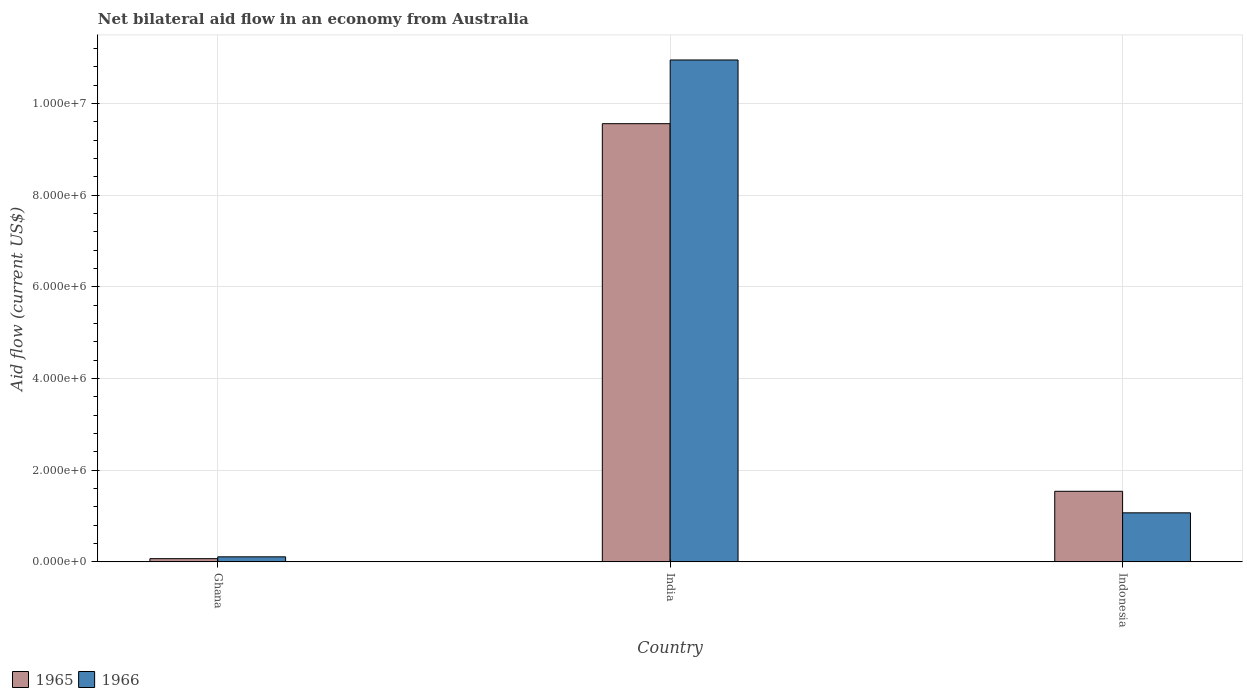How many groups of bars are there?
Provide a succinct answer. 3. How many bars are there on the 3rd tick from the right?
Ensure brevity in your answer.  2. What is the label of the 3rd group of bars from the left?
Provide a short and direct response. Indonesia. What is the net bilateral aid flow in 1965 in Indonesia?
Provide a succinct answer. 1.54e+06. Across all countries, what is the maximum net bilateral aid flow in 1966?
Make the answer very short. 1.10e+07. Across all countries, what is the minimum net bilateral aid flow in 1966?
Provide a succinct answer. 1.10e+05. What is the total net bilateral aid flow in 1965 in the graph?
Give a very brief answer. 1.12e+07. What is the difference between the net bilateral aid flow in 1966 in India and that in Indonesia?
Keep it short and to the point. 9.88e+06. What is the difference between the net bilateral aid flow in 1965 in Ghana and the net bilateral aid flow in 1966 in Indonesia?
Provide a succinct answer. -1.00e+06. What is the average net bilateral aid flow in 1965 per country?
Your response must be concise. 3.72e+06. What is the difference between the net bilateral aid flow of/in 1966 and net bilateral aid flow of/in 1965 in India?
Offer a terse response. 1.39e+06. What is the ratio of the net bilateral aid flow in 1966 in Ghana to that in Indonesia?
Make the answer very short. 0.1. Is the net bilateral aid flow in 1966 in Ghana less than that in India?
Provide a short and direct response. Yes. What is the difference between the highest and the second highest net bilateral aid flow in 1966?
Your answer should be compact. 1.08e+07. What is the difference between the highest and the lowest net bilateral aid flow in 1965?
Provide a succinct answer. 9.49e+06. Is the sum of the net bilateral aid flow in 1966 in Ghana and Indonesia greater than the maximum net bilateral aid flow in 1965 across all countries?
Provide a succinct answer. No. What does the 2nd bar from the left in India represents?
Your response must be concise. 1966. What does the 1st bar from the right in India represents?
Provide a succinct answer. 1966. How many bars are there?
Your answer should be compact. 6. Are all the bars in the graph horizontal?
Your answer should be very brief. No. How many countries are there in the graph?
Your answer should be very brief. 3. Are the values on the major ticks of Y-axis written in scientific E-notation?
Offer a terse response. Yes. Does the graph contain grids?
Keep it short and to the point. Yes. How many legend labels are there?
Give a very brief answer. 2. How are the legend labels stacked?
Provide a succinct answer. Horizontal. What is the title of the graph?
Make the answer very short. Net bilateral aid flow in an economy from Australia. What is the label or title of the Y-axis?
Keep it short and to the point. Aid flow (current US$). What is the Aid flow (current US$) in 1965 in India?
Your response must be concise. 9.56e+06. What is the Aid flow (current US$) in 1966 in India?
Offer a very short reply. 1.10e+07. What is the Aid flow (current US$) of 1965 in Indonesia?
Provide a succinct answer. 1.54e+06. What is the Aid flow (current US$) in 1966 in Indonesia?
Ensure brevity in your answer.  1.07e+06. Across all countries, what is the maximum Aid flow (current US$) in 1965?
Your answer should be compact. 9.56e+06. Across all countries, what is the maximum Aid flow (current US$) in 1966?
Your answer should be very brief. 1.10e+07. What is the total Aid flow (current US$) of 1965 in the graph?
Your answer should be compact. 1.12e+07. What is the total Aid flow (current US$) in 1966 in the graph?
Offer a terse response. 1.21e+07. What is the difference between the Aid flow (current US$) of 1965 in Ghana and that in India?
Make the answer very short. -9.49e+06. What is the difference between the Aid flow (current US$) in 1966 in Ghana and that in India?
Provide a succinct answer. -1.08e+07. What is the difference between the Aid flow (current US$) of 1965 in Ghana and that in Indonesia?
Ensure brevity in your answer.  -1.47e+06. What is the difference between the Aid flow (current US$) in 1966 in Ghana and that in Indonesia?
Make the answer very short. -9.60e+05. What is the difference between the Aid flow (current US$) in 1965 in India and that in Indonesia?
Your answer should be compact. 8.02e+06. What is the difference between the Aid flow (current US$) in 1966 in India and that in Indonesia?
Make the answer very short. 9.88e+06. What is the difference between the Aid flow (current US$) in 1965 in Ghana and the Aid flow (current US$) in 1966 in India?
Make the answer very short. -1.09e+07. What is the difference between the Aid flow (current US$) in 1965 in India and the Aid flow (current US$) in 1966 in Indonesia?
Your response must be concise. 8.49e+06. What is the average Aid flow (current US$) in 1965 per country?
Offer a terse response. 3.72e+06. What is the average Aid flow (current US$) in 1966 per country?
Offer a very short reply. 4.04e+06. What is the difference between the Aid flow (current US$) of 1965 and Aid flow (current US$) of 1966 in India?
Your answer should be very brief. -1.39e+06. What is the difference between the Aid flow (current US$) in 1965 and Aid flow (current US$) in 1966 in Indonesia?
Keep it short and to the point. 4.70e+05. What is the ratio of the Aid flow (current US$) in 1965 in Ghana to that in India?
Ensure brevity in your answer.  0.01. What is the ratio of the Aid flow (current US$) of 1965 in Ghana to that in Indonesia?
Your answer should be very brief. 0.05. What is the ratio of the Aid flow (current US$) of 1966 in Ghana to that in Indonesia?
Your answer should be compact. 0.1. What is the ratio of the Aid flow (current US$) in 1965 in India to that in Indonesia?
Your answer should be very brief. 6.21. What is the ratio of the Aid flow (current US$) of 1966 in India to that in Indonesia?
Provide a succinct answer. 10.23. What is the difference between the highest and the second highest Aid flow (current US$) in 1965?
Keep it short and to the point. 8.02e+06. What is the difference between the highest and the second highest Aid flow (current US$) of 1966?
Provide a short and direct response. 9.88e+06. What is the difference between the highest and the lowest Aid flow (current US$) of 1965?
Provide a short and direct response. 9.49e+06. What is the difference between the highest and the lowest Aid flow (current US$) of 1966?
Your answer should be compact. 1.08e+07. 